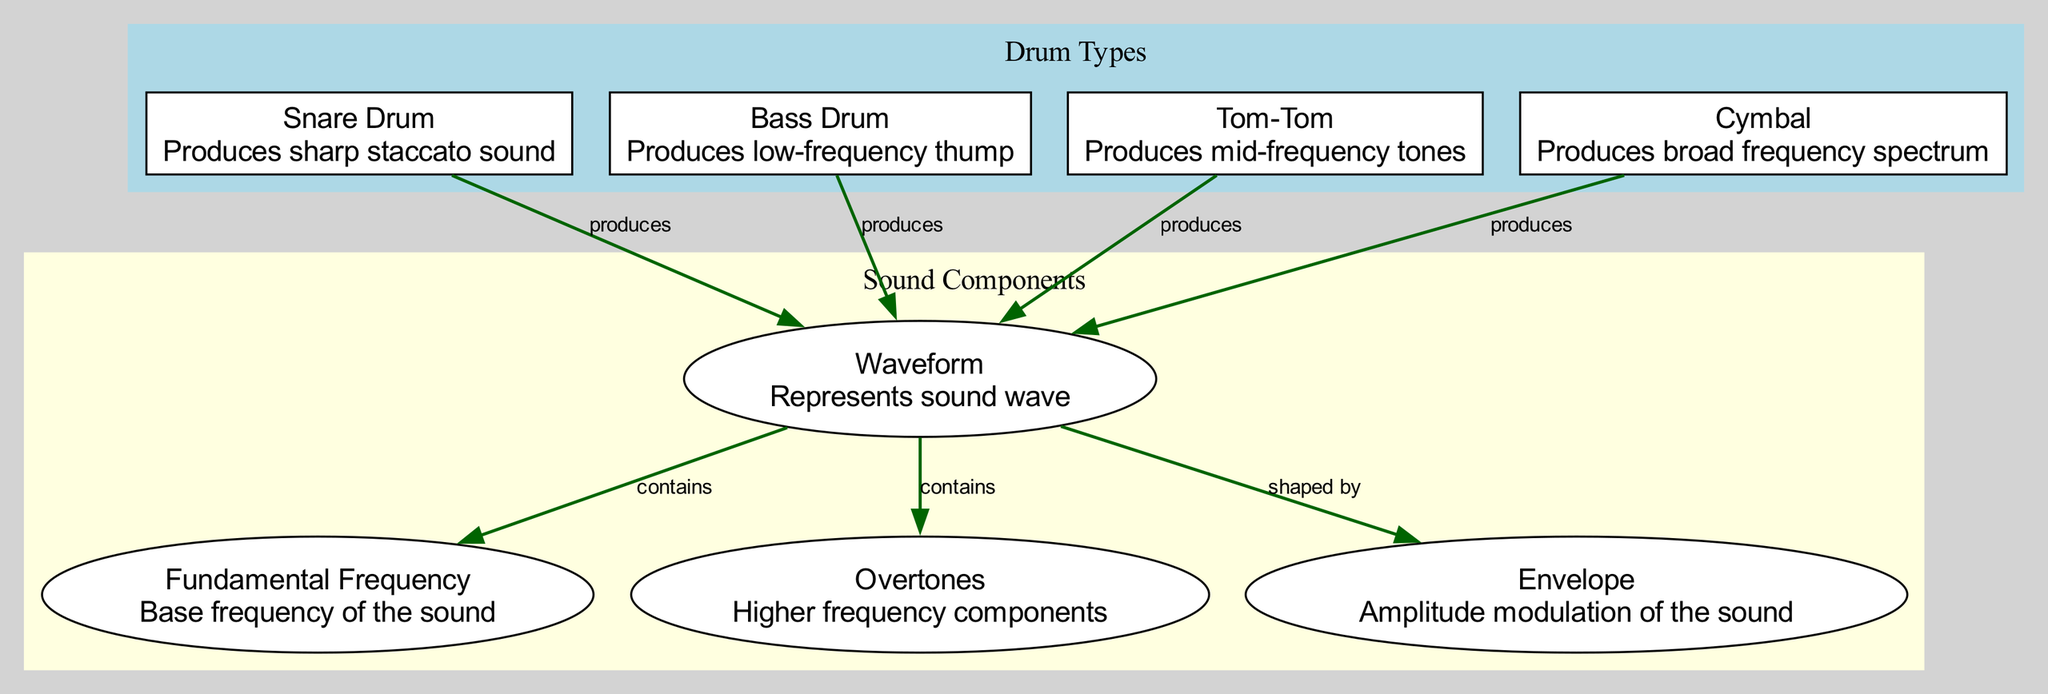What is the fundamental frequency responsible for in this diagram? The fundamental frequency is identified as a key component of the sound waveform, representing the base frequency that gives a sound its pitch. This can be traced directly from the "waveform" node to the "fundamental frequency" node, indicating a direct relationship.
Answer: Base frequency How many types of drums are represented in this diagram? Counting the nodes under the "Drum Types" category, there are four specific types of drums represented: snare drum, bass drum, tom-tom, and cymbal. Each is visually represented within its designated cluster.
Answer: Four Which drum produces a sharp staccato sound? Referring to the node descriptions, the snare drum is defined as the drum that produces a sharp staccato sound, making it easy to identify this characteristic directly from the corresponding node.
Answer: Snare Drum What sound component is shaped by the waveform? Examining the edges leading from the waveform node, it specifically indicates that the envelope is shaped by the waveform, which shows the relationship between these two elements.
Answer: Envelope What type of sound does a cymbal produce? Looking at the description associated with the cymbal node, it specifies that it produces a broad frequency spectrum. This information is straightforwardly contained within its label.
Answer: Broad frequency spectrum What relationship do overtones have with the waveform? According to the edge leading from the waveform to the overtones, the diagram explicitly states that the waveform contains overtones, indicating a direct connection that highlights their relationship.
Answer: Contains How many edges connect the drum types to the waveform? Each drum type in the diagram is shown to have a singular edge connecting it to the waveform. Since there are four drum types, this results in four distinct edges connecting them to the waveform node.
Answer: Four Which drum produces low-frequency sounds? The bass drum is described in the diagram as producing a low-frequency thump, making it easy to identify its contribution by reading its corresponding node description.
Answer: Bass Drum What is the primary function of the waveform represented in the diagram? The waveform serves as the central representation of sound waves generated by the different drum types, which is indicated by all drum types producing it, showing its role in audio representation.
Answer: Represents sound wave 